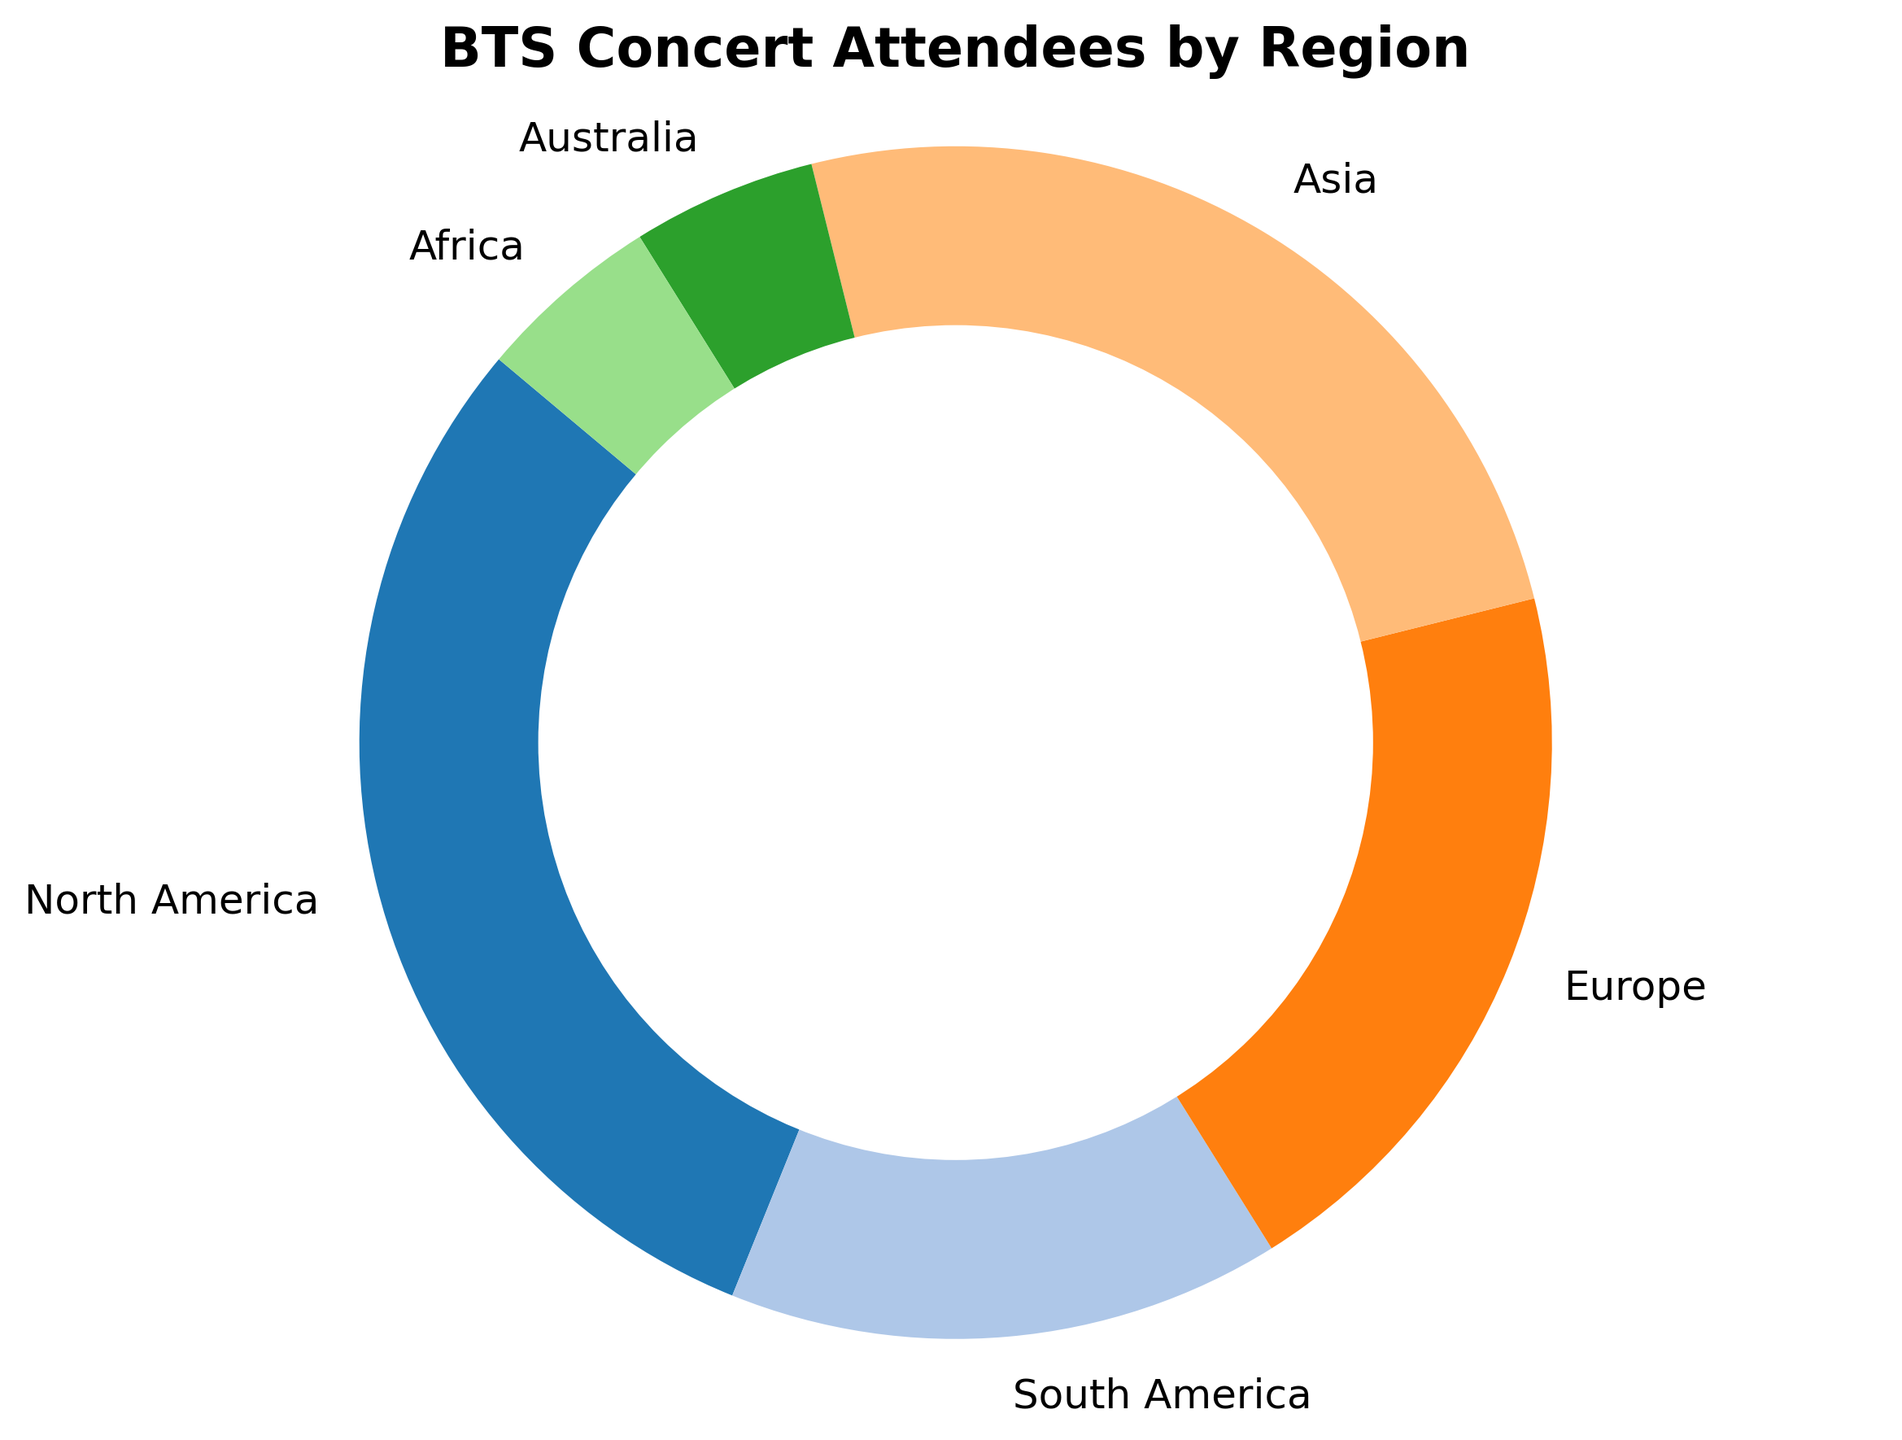What's the region with the highest percentage of BTS concert attendees? The region with the highest percentage can be directly found by identifying the largest segment in the pie chart. North America has the largest segment with 30%.
Answer: North America What's the combined percentage of attendees from South America and Africa? Sum the percentages of South America (15%) and Africa (5%). 15 + 5 = 20%.
Answer: 20% Which continent has a larger percentage of attendees: Europe or Asia? Compare the segments for Europe (20%) and Asia (25%). Asia has a larger segment.
Answer: Asia What is the percentage difference between the North America and Australia attendees? Subtract the percentage of Australia (5%) from North America (30%). 30 - 5 = 25%.
Answer: 25% How many regions have a percentage of attendees greater than 20%? Identify the regions with over 20%, North America (30%) and Asia (25%). There are 2 regions.
Answer: 2 Is the cumulative percentage of attendees from Europe and North America more or less than 50%? Add the percentages of Europe (20%) and North America (30%). 20 + 30 = 50%. The sum is exactly 50%.
Answer: Exactly 50% Which region has a lower percentage of attendees: South America or Africa? Compare the percentages of South America (15%) and Africa (5%). Africa has a lower segment.
Answer: Africa What is the visual difference in the pie chart between Asia and Australia? Observe the segments' sizes and colors. Asia's segment is substantially larger (25%) and more centrally positioned compared to Australia's relatively small (5%) and less prominent segment.
Answer: Asia is larger What percentage of attendees are from regions excluding Asia and Europe? Add the percentages of North America (30%), South America (15%), Australia (5%), and Africa (5%). 30 + 15 + 5 + 5 = 55%.
Answer: 55% Which region contributes the least to the distribution of attendees? Look for the smallest segment in the pie chart. Both Australia and Africa have the smallest segments at 5%.
Answer: Australia and Africa 